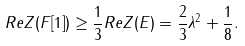<formula> <loc_0><loc_0><loc_500><loc_500>R e Z ( F [ 1 ] ) \geq \frac { 1 } { 3 } R e Z ( E ) = \frac { 2 } { 3 } \lambda ^ { 2 } + \frac { 1 } { 8 } .</formula> 